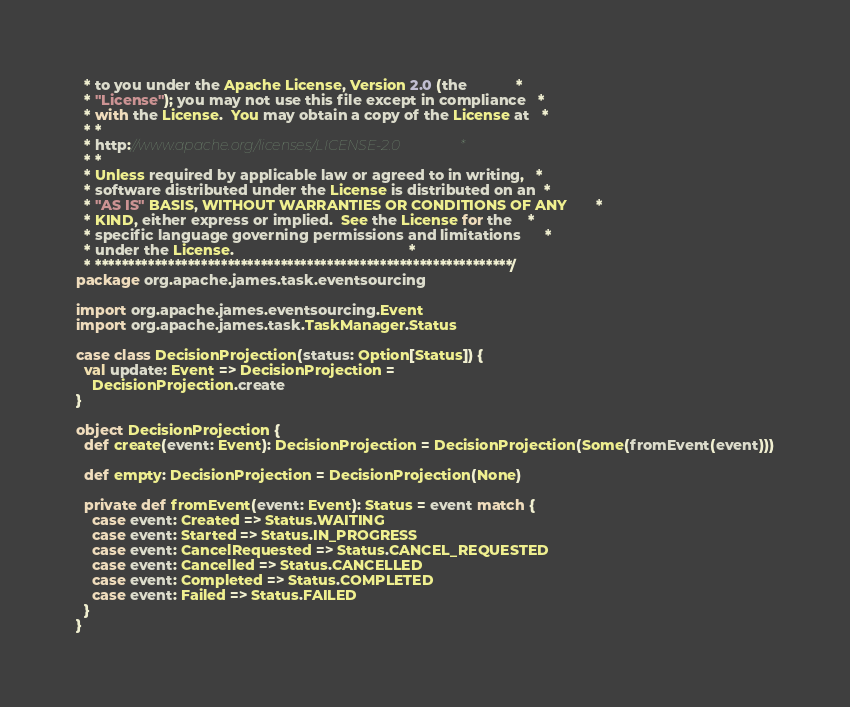<code> <loc_0><loc_0><loc_500><loc_500><_Scala_>  * to you under the Apache License, Version 2.0 (the            *
  * "License"); you may not use this file except in compliance   *
  * with the License.  You may obtain a copy of the License at   *
  * *
  * http://www.apache.org/licenses/LICENSE-2.0                 *
  * *
  * Unless required by applicable law or agreed to in writing,   *
  * software distributed under the License is distributed on an  *
  * "AS IS" BASIS, WITHOUT WARRANTIES OR CONDITIONS OF ANY       *
  * KIND, either express or implied.  See the License for the    *
  * specific language governing permissions and limitations      *
  * under the License.                                           *
  * ***************************************************************/
package org.apache.james.task.eventsourcing

import org.apache.james.eventsourcing.Event
import org.apache.james.task.TaskManager.Status

case class DecisionProjection(status: Option[Status]) {
  val update: Event => DecisionProjection =
    DecisionProjection.create
}

object DecisionProjection {
  def create(event: Event): DecisionProjection = DecisionProjection(Some(fromEvent(event)))

  def empty: DecisionProjection = DecisionProjection(None)

  private def fromEvent(event: Event): Status = event match {
    case event: Created => Status.WAITING
    case event: Started => Status.IN_PROGRESS
    case event: CancelRequested => Status.CANCEL_REQUESTED
    case event: Cancelled => Status.CANCELLED
    case event: Completed => Status.COMPLETED
    case event: Failed => Status.FAILED
  }
}

</code> 